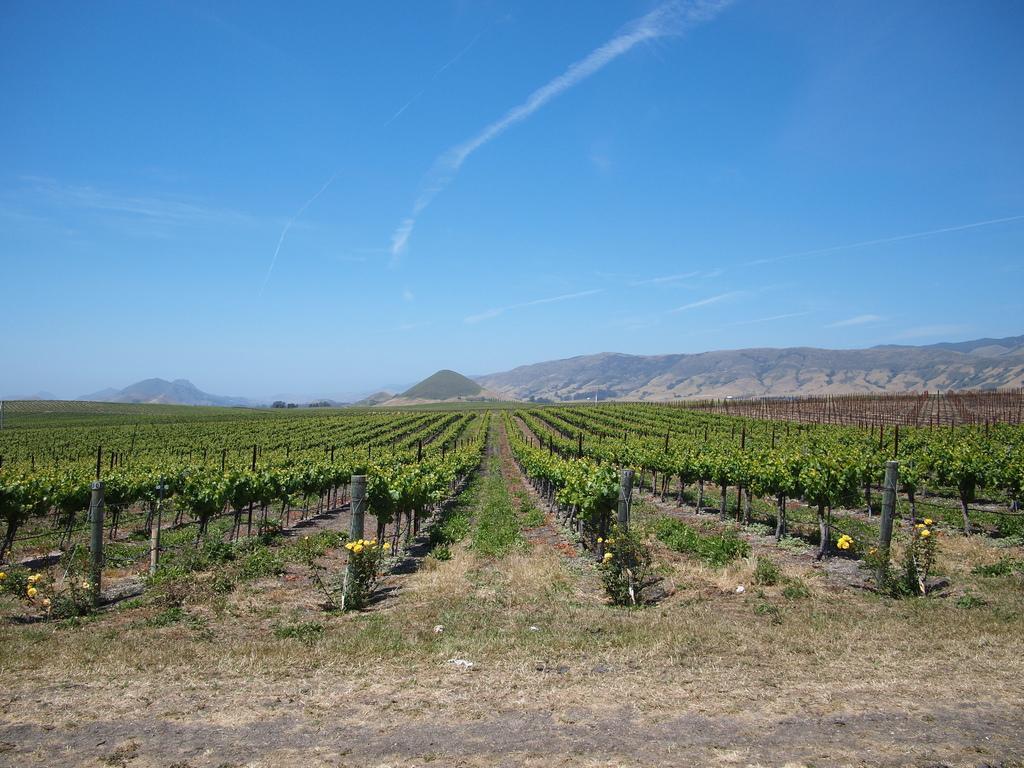Could you give a brief overview of what you see in this image? In this image we can see many plants on the ground. At the bottom of the image we can see ground and grass. In the background there is a hill, sky and clouds. 